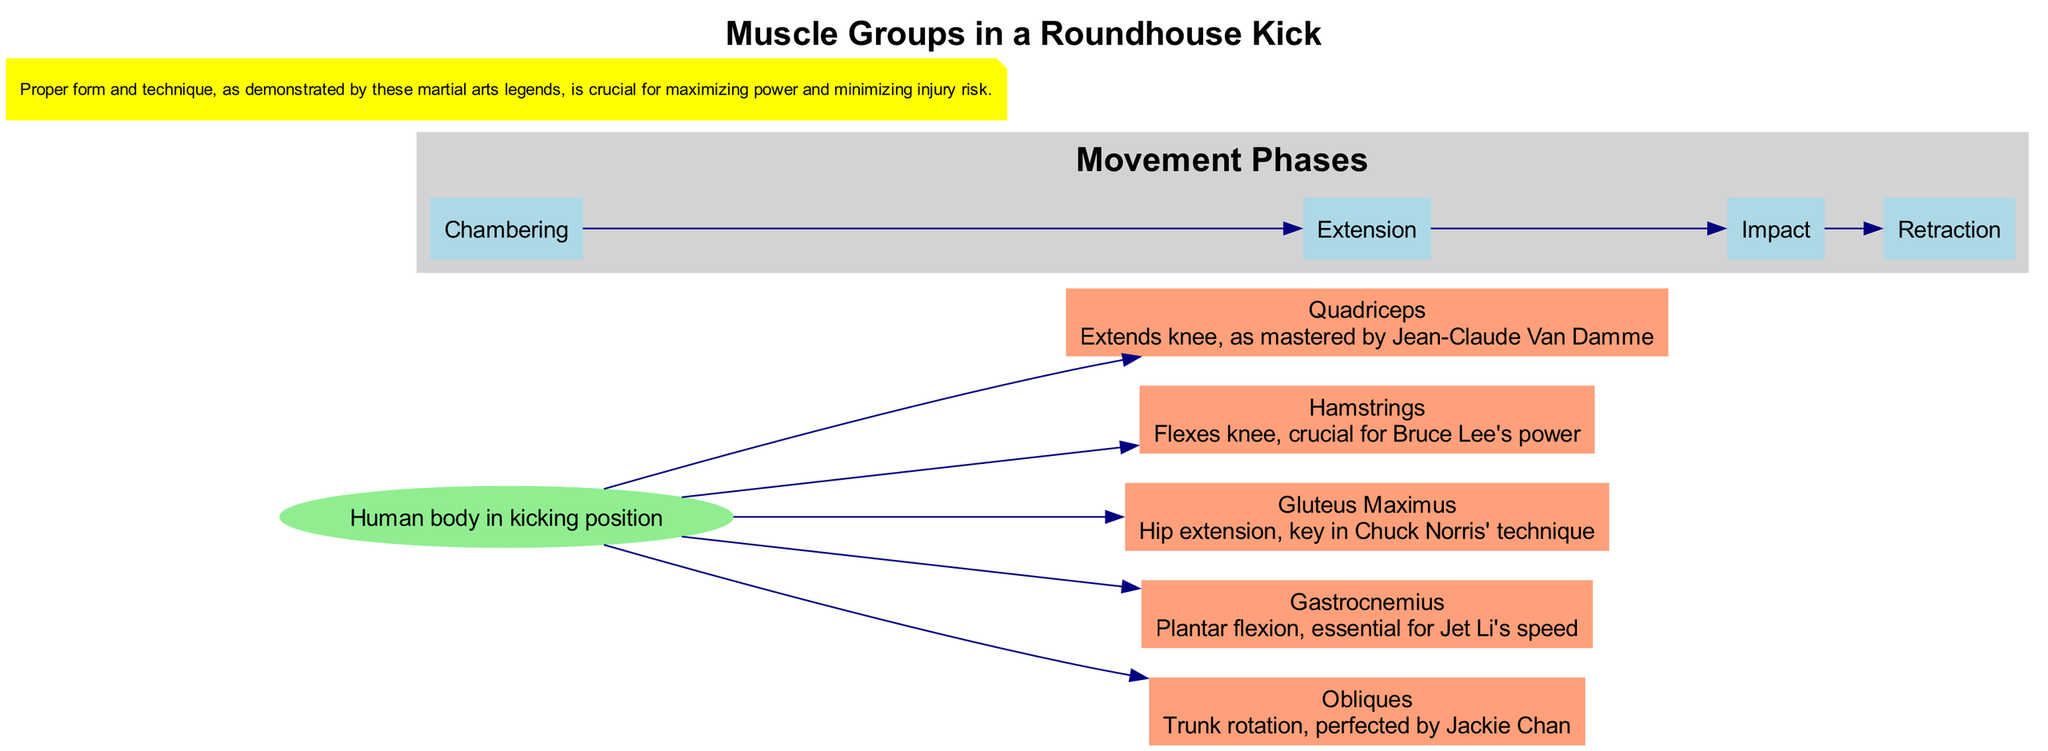What is the title of the diagram? The diagram's title is explicitly stated at the top.
Answer: Muscle Groups in a Roundhouse Kick How many major muscle groups are shown? By counting the nodes representing muscle groups in the diagram, we can determine the total number.
Answer: 5 Which muscle group is responsible for knee extension? The description of the muscle groups specifically indicates which one extends the knee.
Answer: Quadriceps Who perfected trunk rotation according to the diagram? Look for the muscle group associated with trunk rotation and check its description. The name following the description provides the answer.
Answer: Jackie Chan Which movement phase comes after Impact? The movement phases are arranged in a chronological order, allowing us to identify the next phase after the one mentioned.
Answer: Retraction How does the Hamstrings muscle group contribute to a roundhouse kick? The description says it flexes the knee, which is essential for the kick's power.
Answer: Flexes knee What is essential for Jet Li's speed in the roundhouse kick? The diagram mentions the Gastrocnemius's role in plantar flexion, which is vital for speed.
Answer: Plantar flexion Which muscle group is key in Chuck Norris' technique? Referring to the description of the relevant muscle group clarifies its association with his technique.
Answer: Gluteus Maximus What is the main figure depicted in the diagram? The main figure node describes what it represents visually in the diagram.
Answer: Human body in kicking position 